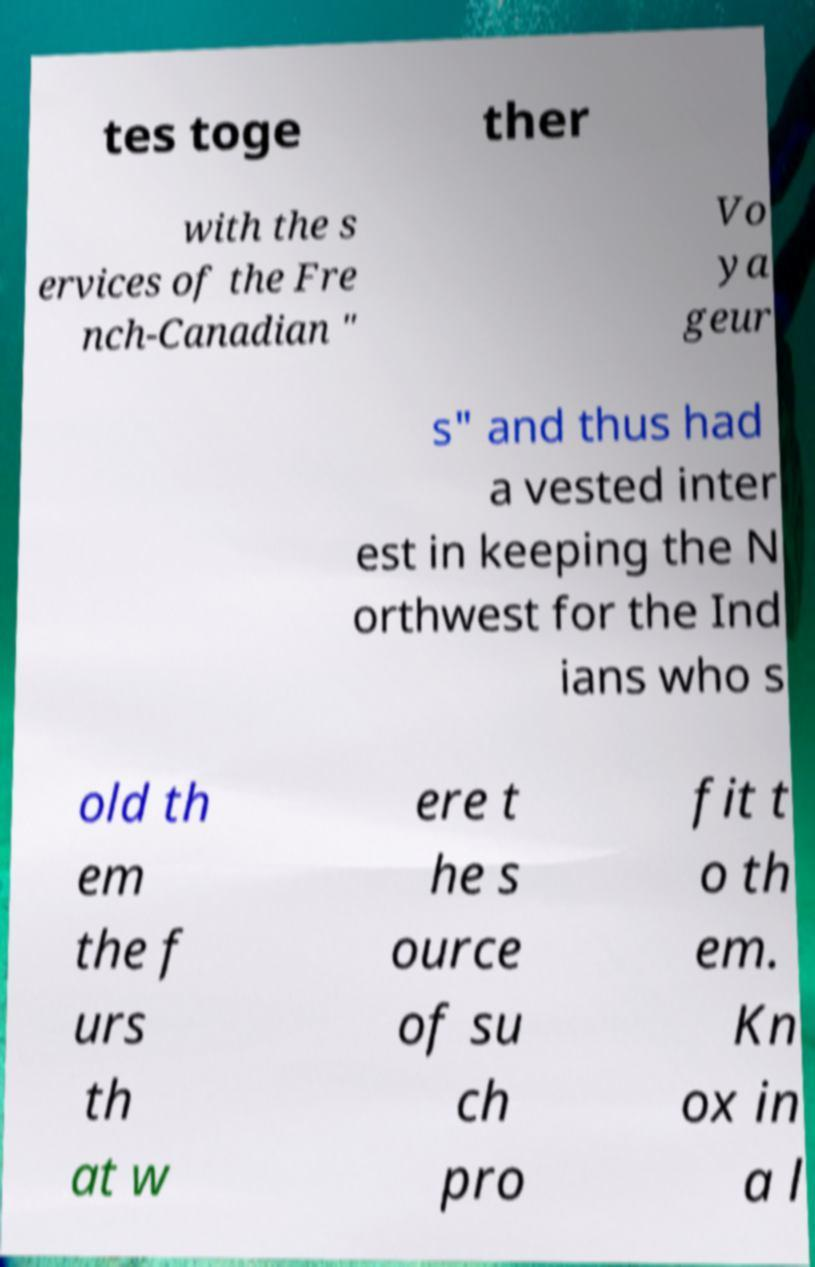What messages or text are displayed in this image? I need them in a readable, typed format. tes toge ther with the s ervices of the Fre nch-Canadian " Vo ya geur s" and thus had a vested inter est in keeping the N orthwest for the Ind ians who s old th em the f urs th at w ere t he s ource of su ch pro fit t o th em. Kn ox in a l 